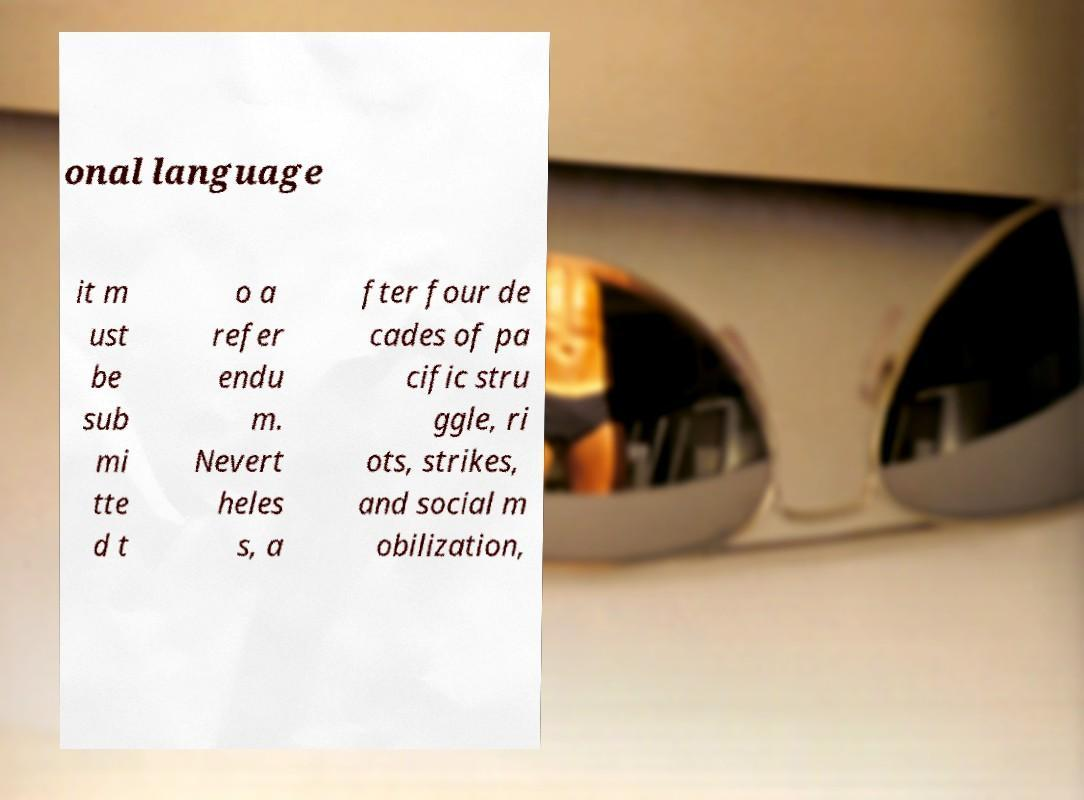Could you assist in decoding the text presented in this image and type it out clearly? onal language it m ust be sub mi tte d t o a refer endu m. Nevert heles s, a fter four de cades of pa cific stru ggle, ri ots, strikes, and social m obilization, 